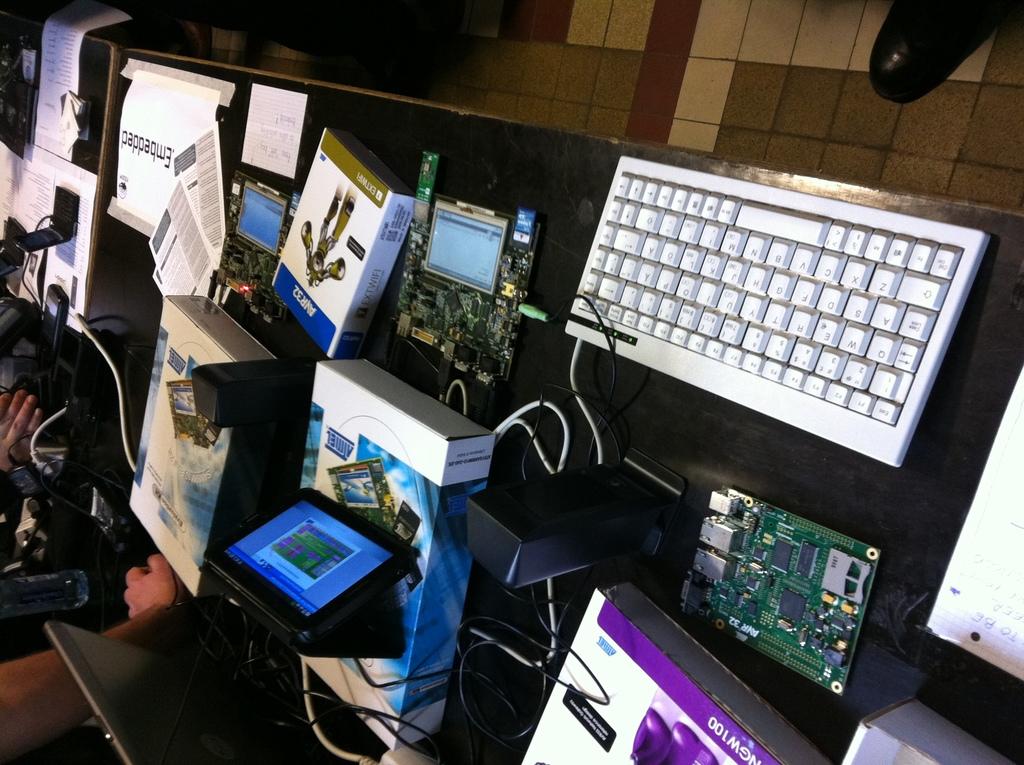What is printed in the blue banner above the robot?
Ensure brevity in your answer.  Ayr32. What is printed on the white sheet of paper on the top left?
Your answer should be compact. Embedded. 